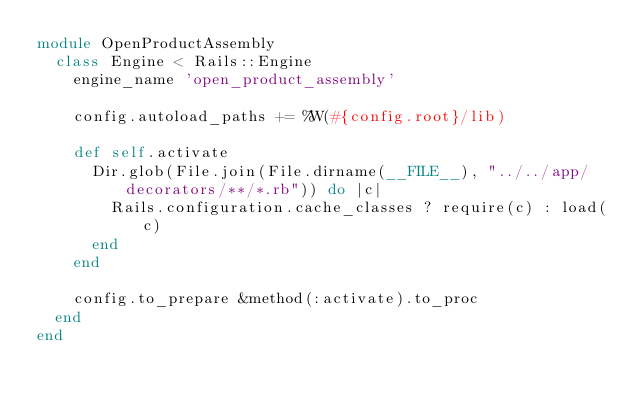Convert code to text. <code><loc_0><loc_0><loc_500><loc_500><_Ruby_>module OpenProductAssembly
  class Engine < Rails::Engine
    engine_name 'open_product_assembly'

    config.autoload_paths += %W(#{config.root}/lib)

    def self.activate
      Dir.glob(File.join(File.dirname(__FILE__), "../../app/decorators/**/*.rb")) do |c|
        Rails.configuration.cache_classes ? require(c) : load(c)
      end
    end

    config.to_prepare &method(:activate).to_proc
  end
end</code> 